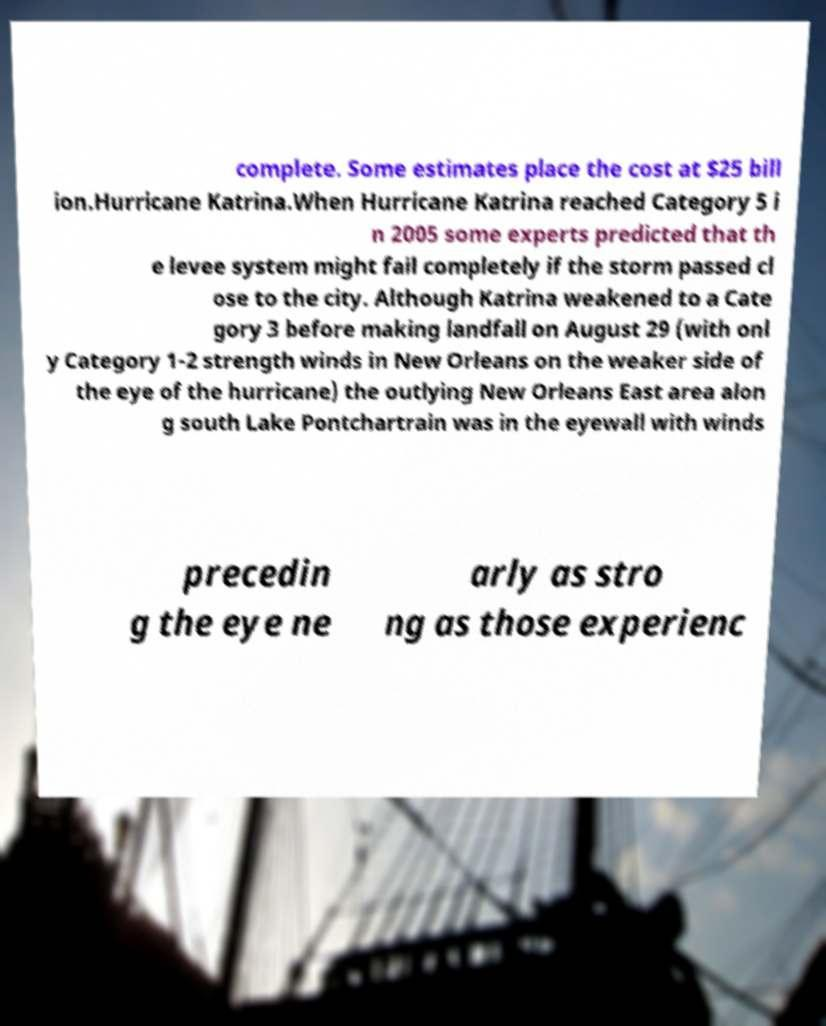For documentation purposes, I need the text within this image transcribed. Could you provide that? complete. Some estimates place the cost at $25 bill ion.Hurricane Katrina.When Hurricane Katrina reached Category 5 i n 2005 some experts predicted that th e levee system might fail completely if the storm passed cl ose to the city. Although Katrina weakened to a Cate gory 3 before making landfall on August 29 (with onl y Category 1-2 strength winds in New Orleans on the weaker side of the eye of the hurricane) the outlying New Orleans East area alon g south Lake Pontchartrain was in the eyewall with winds precedin g the eye ne arly as stro ng as those experienc 